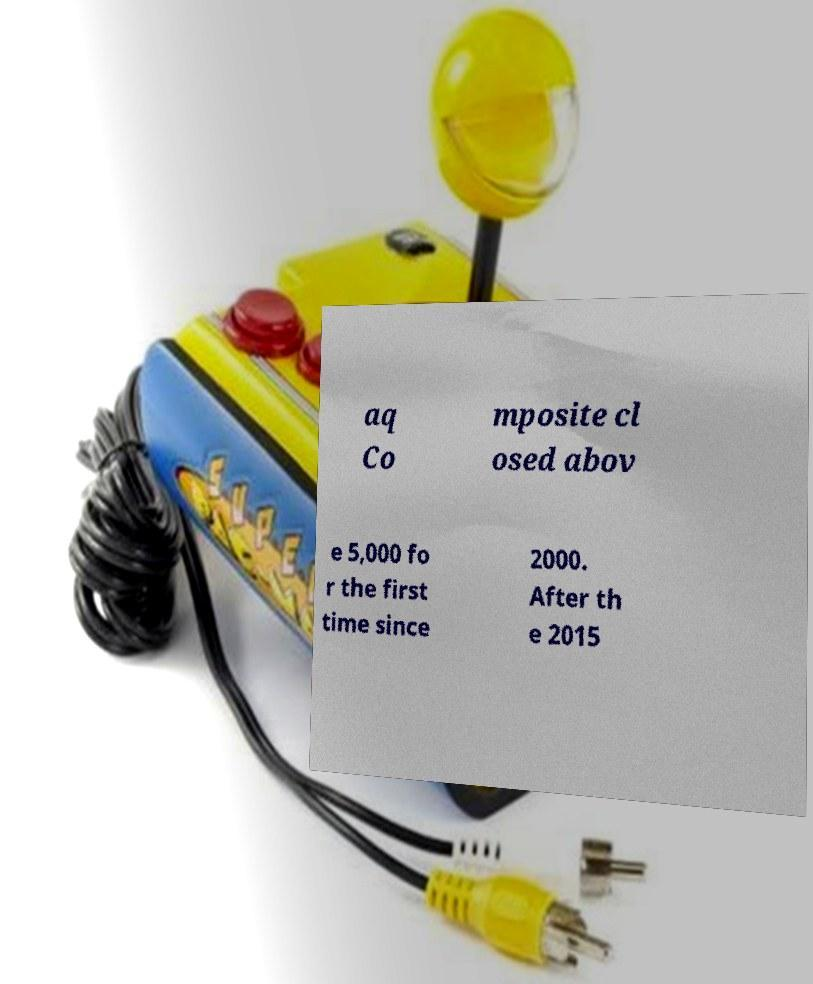Could you assist in decoding the text presented in this image and type it out clearly? aq Co mposite cl osed abov e 5,000 fo r the first time since 2000. After th e 2015 